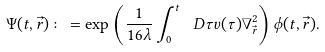<formula> <loc_0><loc_0><loc_500><loc_500>\Psi ( t , \vec { r } ) \colon = \exp \left ( \frac { 1 } { 1 6 \lambda } \int _ { 0 } ^ { t } \, \ D \tau v ( \tau ) \nabla ^ { 2 } _ { \vec { r } } \right ) \phi ( t , \vec { r } ) .</formula> 